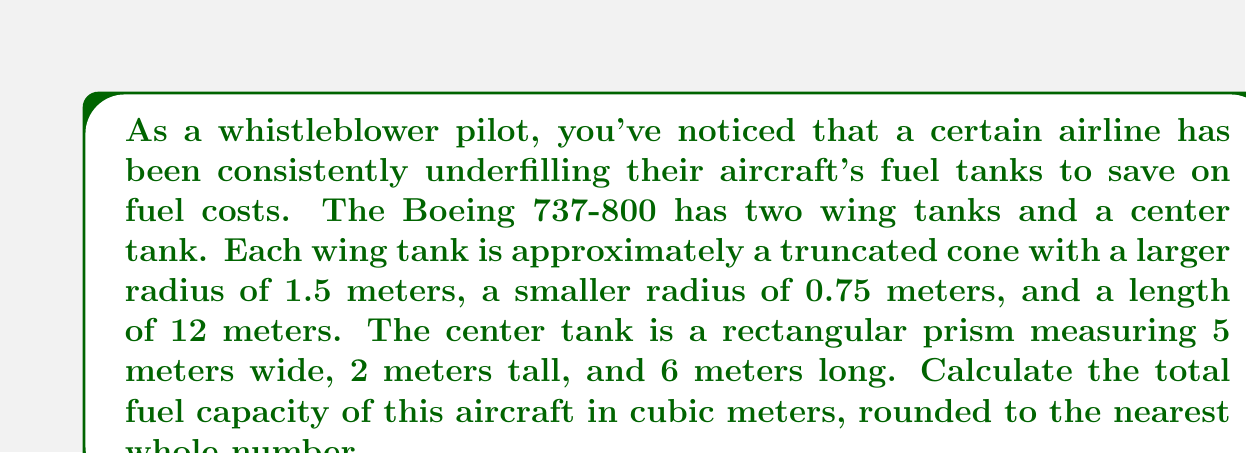Show me your answer to this math problem. To solve this problem, we need to calculate the volume of each tank and then sum them up:

1. Wing tanks (2):
   The volume of a truncated cone is given by the formula:
   $$V = \frac{1}{3}\pi h(R^2 + r^2 + Rr)$$
   where $h$ is the height (length in this case), $R$ is the larger radius, and $r$ is the smaller radius.

   For each wing tank:
   $$V_{wing} = \frac{1}{3}\pi \cdot 12(1.5^2 + 0.75^2 + 1.5 \cdot 0.75)$$
   $$V_{wing} = 4\pi(2.25 + 0.5625 + 1.125)$$
   $$V_{wing} = 4\pi \cdot 3.9375 = 15.7\pi \approx 49.32 \text{ m}^3$$

   Total volume for both wing tanks:
   $$V_{wings} = 2 \cdot 49.32 = 98.64 \text{ m}^3$$

2. Center tank:
   The volume of a rectangular prism is given by length × width × height:
   $$V_{center} = 5 \cdot 2 \cdot 6 = 60 \text{ m}^3$$

3. Total fuel capacity:
   $$V_{total} = V_{wings} + V_{center} = 98.64 + 60 = 158.64 \text{ m}^3$$

Rounding to the nearest whole number: 159 m³
Answer: 159 m³ 